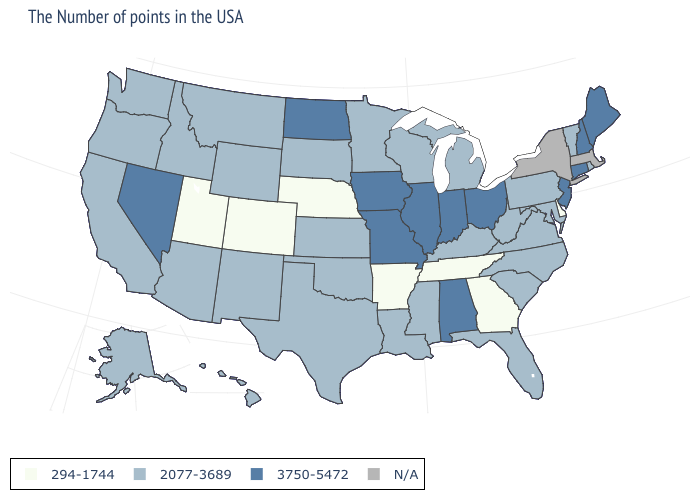Name the states that have a value in the range 3750-5472?
Be succinct. Maine, New Hampshire, Connecticut, New Jersey, Ohio, Indiana, Alabama, Illinois, Missouri, Iowa, North Dakota, Nevada. What is the value of Colorado?
Answer briefly. 294-1744. Which states have the lowest value in the MidWest?
Concise answer only. Nebraska. What is the value of Indiana?
Write a very short answer. 3750-5472. Does Maryland have the highest value in the USA?
Be succinct. No. Name the states that have a value in the range 294-1744?
Be succinct. Delaware, Georgia, Tennessee, Arkansas, Nebraska, Colorado, Utah. How many symbols are there in the legend?
Keep it brief. 4. Name the states that have a value in the range 2077-3689?
Give a very brief answer. Rhode Island, Vermont, Maryland, Pennsylvania, Virginia, North Carolina, South Carolina, West Virginia, Florida, Michigan, Kentucky, Wisconsin, Mississippi, Louisiana, Minnesota, Kansas, Oklahoma, Texas, South Dakota, Wyoming, New Mexico, Montana, Arizona, Idaho, California, Washington, Oregon, Alaska, Hawaii. What is the value of Oklahoma?
Short answer required. 2077-3689. What is the lowest value in the MidWest?
Write a very short answer. 294-1744. Does the first symbol in the legend represent the smallest category?
Answer briefly. Yes. Does Rhode Island have the highest value in the USA?
Be succinct. No. What is the value of Indiana?
Answer briefly. 3750-5472. Name the states that have a value in the range 294-1744?
Give a very brief answer. Delaware, Georgia, Tennessee, Arkansas, Nebraska, Colorado, Utah. 